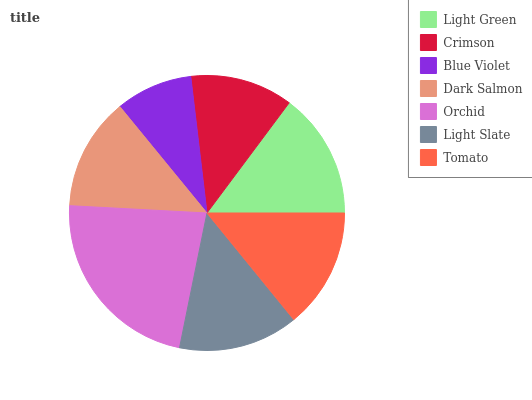Is Blue Violet the minimum?
Answer yes or no. Yes. Is Orchid the maximum?
Answer yes or no. Yes. Is Crimson the minimum?
Answer yes or no. No. Is Crimson the maximum?
Answer yes or no. No. Is Light Green greater than Crimson?
Answer yes or no. Yes. Is Crimson less than Light Green?
Answer yes or no. Yes. Is Crimson greater than Light Green?
Answer yes or no. No. Is Light Green less than Crimson?
Answer yes or no. No. Is Light Slate the high median?
Answer yes or no. Yes. Is Light Slate the low median?
Answer yes or no. Yes. Is Dark Salmon the high median?
Answer yes or no. No. Is Light Green the low median?
Answer yes or no. No. 